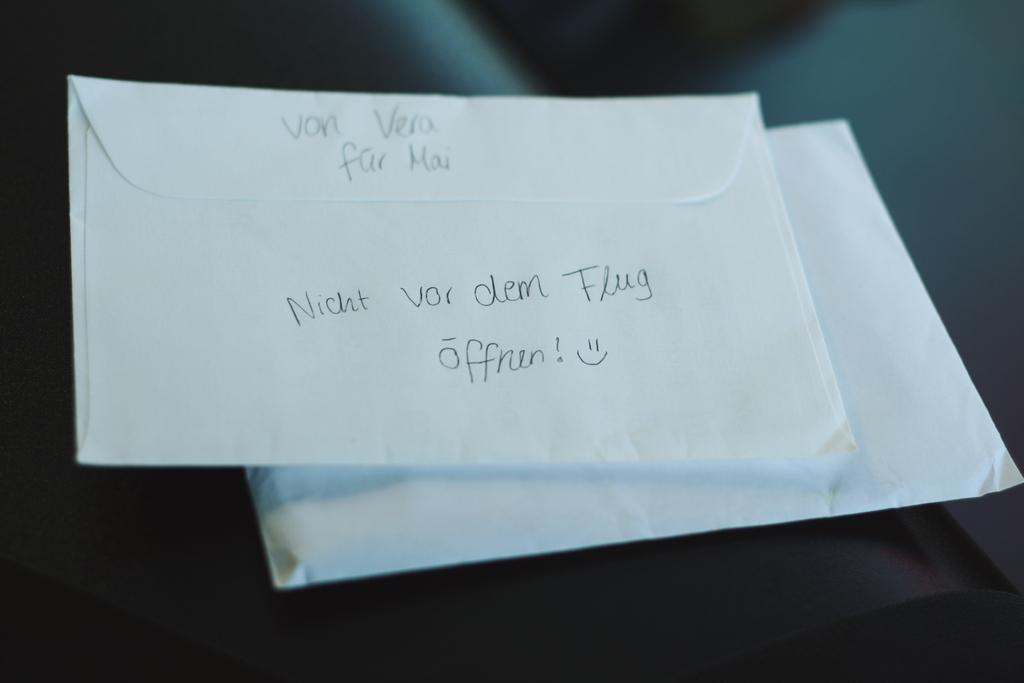Provide a one-sentence caption for the provided image. Two envelopes with some writing in the back that appears to be in German. 